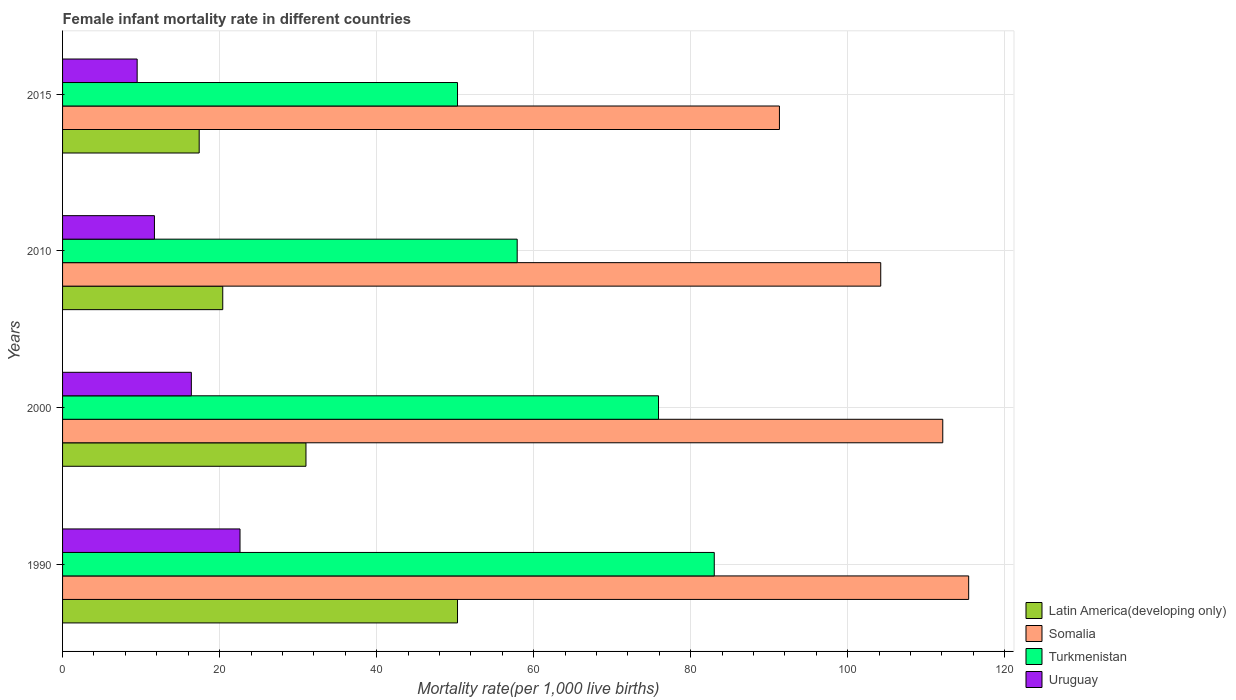How many different coloured bars are there?
Offer a very short reply. 4. How many groups of bars are there?
Give a very brief answer. 4. Are the number of bars per tick equal to the number of legend labels?
Your answer should be very brief. Yes. Are the number of bars on each tick of the Y-axis equal?
Your response must be concise. Yes. How many bars are there on the 4th tick from the top?
Ensure brevity in your answer.  4. How many bars are there on the 2nd tick from the bottom?
Provide a succinct answer. 4. What is the label of the 2nd group of bars from the top?
Offer a terse response. 2010. In how many cases, is the number of bars for a given year not equal to the number of legend labels?
Ensure brevity in your answer.  0. What is the female infant mortality rate in Uruguay in 2000?
Provide a succinct answer. 16.4. Across all years, what is the maximum female infant mortality rate in Somalia?
Give a very brief answer. 115.4. Across all years, what is the minimum female infant mortality rate in Somalia?
Keep it short and to the point. 91.3. In which year was the female infant mortality rate in Turkmenistan minimum?
Make the answer very short. 2015. What is the total female infant mortality rate in Latin America(developing only) in the graph?
Give a very brief answer. 119.1. What is the difference between the female infant mortality rate in Latin America(developing only) in 1990 and that in 2000?
Your response must be concise. 19.3. What is the difference between the female infant mortality rate in Somalia in 1990 and the female infant mortality rate in Latin America(developing only) in 2000?
Your answer should be compact. 84.4. What is the average female infant mortality rate in Somalia per year?
Your answer should be compact. 105.75. In the year 1990, what is the difference between the female infant mortality rate in Latin America(developing only) and female infant mortality rate in Turkmenistan?
Offer a terse response. -32.7. In how many years, is the female infant mortality rate in Uruguay greater than 88 ?
Give a very brief answer. 0. What is the ratio of the female infant mortality rate in Latin America(developing only) in 2000 to that in 2010?
Offer a terse response. 1.52. Is the difference between the female infant mortality rate in Latin America(developing only) in 1990 and 2010 greater than the difference between the female infant mortality rate in Turkmenistan in 1990 and 2010?
Offer a terse response. Yes. What is the difference between the highest and the second highest female infant mortality rate in Uruguay?
Keep it short and to the point. 6.2. What is the difference between the highest and the lowest female infant mortality rate in Somalia?
Ensure brevity in your answer.  24.1. In how many years, is the female infant mortality rate in Uruguay greater than the average female infant mortality rate in Uruguay taken over all years?
Ensure brevity in your answer.  2. What does the 3rd bar from the top in 1990 represents?
Provide a succinct answer. Somalia. What does the 2nd bar from the bottom in 1990 represents?
Your answer should be compact. Somalia. Are all the bars in the graph horizontal?
Provide a succinct answer. Yes. Does the graph contain grids?
Offer a very short reply. Yes. What is the title of the graph?
Provide a succinct answer. Female infant mortality rate in different countries. What is the label or title of the X-axis?
Make the answer very short. Mortality rate(per 1,0 live births). What is the label or title of the Y-axis?
Offer a terse response. Years. What is the Mortality rate(per 1,000 live births) of Latin America(developing only) in 1990?
Your answer should be very brief. 50.3. What is the Mortality rate(per 1,000 live births) in Somalia in 1990?
Your response must be concise. 115.4. What is the Mortality rate(per 1,000 live births) of Turkmenistan in 1990?
Make the answer very short. 83. What is the Mortality rate(per 1,000 live births) in Uruguay in 1990?
Keep it short and to the point. 22.6. What is the Mortality rate(per 1,000 live births) of Latin America(developing only) in 2000?
Provide a succinct answer. 31. What is the Mortality rate(per 1,000 live births) of Somalia in 2000?
Give a very brief answer. 112.1. What is the Mortality rate(per 1,000 live births) of Turkmenistan in 2000?
Make the answer very short. 75.9. What is the Mortality rate(per 1,000 live births) in Uruguay in 2000?
Give a very brief answer. 16.4. What is the Mortality rate(per 1,000 live births) of Latin America(developing only) in 2010?
Provide a short and direct response. 20.4. What is the Mortality rate(per 1,000 live births) of Somalia in 2010?
Give a very brief answer. 104.2. What is the Mortality rate(per 1,000 live births) in Turkmenistan in 2010?
Offer a terse response. 57.9. What is the Mortality rate(per 1,000 live births) of Somalia in 2015?
Your answer should be very brief. 91.3. What is the Mortality rate(per 1,000 live births) of Turkmenistan in 2015?
Offer a very short reply. 50.3. Across all years, what is the maximum Mortality rate(per 1,000 live births) of Latin America(developing only)?
Ensure brevity in your answer.  50.3. Across all years, what is the maximum Mortality rate(per 1,000 live births) in Somalia?
Offer a very short reply. 115.4. Across all years, what is the maximum Mortality rate(per 1,000 live births) of Turkmenistan?
Keep it short and to the point. 83. Across all years, what is the maximum Mortality rate(per 1,000 live births) in Uruguay?
Offer a very short reply. 22.6. Across all years, what is the minimum Mortality rate(per 1,000 live births) in Latin America(developing only)?
Your response must be concise. 17.4. Across all years, what is the minimum Mortality rate(per 1,000 live births) of Somalia?
Give a very brief answer. 91.3. Across all years, what is the minimum Mortality rate(per 1,000 live births) in Turkmenistan?
Provide a succinct answer. 50.3. Across all years, what is the minimum Mortality rate(per 1,000 live births) of Uruguay?
Ensure brevity in your answer.  9.5. What is the total Mortality rate(per 1,000 live births) in Latin America(developing only) in the graph?
Your answer should be very brief. 119.1. What is the total Mortality rate(per 1,000 live births) in Somalia in the graph?
Give a very brief answer. 423. What is the total Mortality rate(per 1,000 live births) of Turkmenistan in the graph?
Your answer should be very brief. 267.1. What is the total Mortality rate(per 1,000 live births) in Uruguay in the graph?
Your answer should be compact. 60.2. What is the difference between the Mortality rate(per 1,000 live births) of Latin America(developing only) in 1990 and that in 2000?
Offer a terse response. 19.3. What is the difference between the Mortality rate(per 1,000 live births) in Uruguay in 1990 and that in 2000?
Your response must be concise. 6.2. What is the difference between the Mortality rate(per 1,000 live births) in Latin America(developing only) in 1990 and that in 2010?
Give a very brief answer. 29.9. What is the difference between the Mortality rate(per 1,000 live births) in Somalia in 1990 and that in 2010?
Offer a terse response. 11.2. What is the difference between the Mortality rate(per 1,000 live births) of Turkmenistan in 1990 and that in 2010?
Offer a terse response. 25.1. What is the difference between the Mortality rate(per 1,000 live births) of Uruguay in 1990 and that in 2010?
Your answer should be very brief. 10.9. What is the difference between the Mortality rate(per 1,000 live births) of Latin America(developing only) in 1990 and that in 2015?
Keep it short and to the point. 32.9. What is the difference between the Mortality rate(per 1,000 live births) in Somalia in 1990 and that in 2015?
Provide a short and direct response. 24.1. What is the difference between the Mortality rate(per 1,000 live births) of Turkmenistan in 1990 and that in 2015?
Give a very brief answer. 32.7. What is the difference between the Mortality rate(per 1,000 live births) of Uruguay in 1990 and that in 2015?
Offer a terse response. 13.1. What is the difference between the Mortality rate(per 1,000 live births) in Latin America(developing only) in 2000 and that in 2010?
Provide a short and direct response. 10.6. What is the difference between the Mortality rate(per 1,000 live births) of Somalia in 2000 and that in 2010?
Make the answer very short. 7.9. What is the difference between the Mortality rate(per 1,000 live births) of Turkmenistan in 2000 and that in 2010?
Give a very brief answer. 18. What is the difference between the Mortality rate(per 1,000 live births) in Somalia in 2000 and that in 2015?
Keep it short and to the point. 20.8. What is the difference between the Mortality rate(per 1,000 live births) in Turkmenistan in 2000 and that in 2015?
Your answer should be very brief. 25.6. What is the difference between the Mortality rate(per 1,000 live births) of Latin America(developing only) in 2010 and that in 2015?
Your answer should be very brief. 3. What is the difference between the Mortality rate(per 1,000 live births) in Somalia in 2010 and that in 2015?
Provide a succinct answer. 12.9. What is the difference between the Mortality rate(per 1,000 live births) of Uruguay in 2010 and that in 2015?
Your response must be concise. 2.2. What is the difference between the Mortality rate(per 1,000 live births) of Latin America(developing only) in 1990 and the Mortality rate(per 1,000 live births) of Somalia in 2000?
Your response must be concise. -61.8. What is the difference between the Mortality rate(per 1,000 live births) in Latin America(developing only) in 1990 and the Mortality rate(per 1,000 live births) in Turkmenistan in 2000?
Your response must be concise. -25.6. What is the difference between the Mortality rate(per 1,000 live births) in Latin America(developing only) in 1990 and the Mortality rate(per 1,000 live births) in Uruguay in 2000?
Keep it short and to the point. 33.9. What is the difference between the Mortality rate(per 1,000 live births) of Somalia in 1990 and the Mortality rate(per 1,000 live births) of Turkmenistan in 2000?
Give a very brief answer. 39.5. What is the difference between the Mortality rate(per 1,000 live births) in Turkmenistan in 1990 and the Mortality rate(per 1,000 live births) in Uruguay in 2000?
Make the answer very short. 66.6. What is the difference between the Mortality rate(per 1,000 live births) in Latin America(developing only) in 1990 and the Mortality rate(per 1,000 live births) in Somalia in 2010?
Offer a terse response. -53.9. What is the difference between the Mortality rate(per 1,000 live births) in Latin America(developing only) in 1990 and the Mortality rate(per 1,000 live births) in Uruguay in 2010?
Ensure brevity in your answer.  38.6. What is the difference between the Mortality rate(per 1,000 live births) of Somalia in 1990 and the Mortality rate(per 1,000 live births) of Turkmenistan in 2010?
Your answer should be compact. 57.5. What is the difference between the Mortality rate(per 1,000 live births) of Somalia in 1990 and the Mortality rate(per 1,000 live births) of Uruguay in 2010?
Your response must be concise. 103.7. What is the difference between the Mortality rate(per 1,000 live births) of Turkmenistan in 1990 and the Mortality rate(per 1,000 live births) of Uruguay in 2010?
Make the answer very short. 71.3. What is the difference between the Mortality rate(per 1,000 live births) in Latin America(developing only) in 1990 and the Mortality rate(per 1,000 live births) in Somalia in 2015?
Ensure brevity in your answer.  -41. What is the difference between the Mortality rate(per 1,000 live births) in Latin America(developing only) in 1990 and the Mortality rate(per 1,000 live births) in Uruguay in 2015?
Provide a succinct answer. 40.8. What is the difference between the Mortality rate(per 1,000 live births) of Somalia in 1990 and the Mortality rate(per 1,000 live births) of Turkmenistan in 2015?
Your answer should be compact. 65.1. What is the difference between the Mortality rate(per 1,000 live births) of Somalia in 1990 and the Mortality rate(per 1,000 live births) of Uruguay in 2015?
Provide a short and direct response. 105.9. What is the difference between the Mortality rate(per 1,000 live births) in Turkmenistan in 1990 and the Mortality rate(per 1,000 live births) in Uruguay in 2015?
Your answer should be very brief. 73.5. What is the difference between the Mortality rate(per 1,000 live births) of Latin America(developing only) in 2000 and the Mortality rate(per 1,000 live births) of Somalia in 2010?
Provide a short and direct response. -73.2. What is the difference between the Mortality rate(per 1,000 live births) of Latin America(developing only) in 2000 and the Mortality rate(per 1,000 live births) of Turkmenistan in 2010?
Give a very brief answer. -26.9. What is the difference between the Mortality rate(per 1,000 live births) of Latin America(developing only) in 2000 and the Mortality rate(per 1,000 live births) of Uruguay in 2010?
Provide a succinct answer. 19.3. What is the difference between the Mortality rate(per 1,000 live births) of Somalia in 2000 and the Mortality rate(per 1,000 live births) of Turkmenistan in 2010?
Your answer should be very brief. 54.2. What is the difference between the Mortality rate(per 1,000 live births) in Somalia in 2000 and the Mortality rate(per 1,000 live births) in Uruguay in 2010?
Offer a terse response. 100.4. What is the difference between the Mortality rate(per 1,000 live births) of Turkmenistan in 2000 and the Mortality rate(per 1,000 live births) of Uruguay in 2010?
Your answer should be compact. 64.2. What is the difference between the Mortality rate(per 1,000 live births) of Latin America(developing only) in 2000 and the Mortality rate(per 1,000 live births) of Somalia in 2015?
Ensure brevity in your answer.  -60.3. What is the difference between the Mortality rate(per 1,000 live births) of Latin America(developing only) in 2000 and the Mortality rate(per 1,000 live births) of Turkmenistan in 2015?
Your answer should be very brief. -19.3. What is the difference between the Mortality rate(per 1,000 live births) in Latin America(developing only) in 2000 and the Mortality rate(per 1,000 live births) in Uruguay in 2015?
Provide a short and direct response. 21.5. What is the difference between the Mortality rate(per 1,000 live births) in Somalia in 2000 and the Mortality rate(per 1,000 live births) in Turkmenistan in 2015?
Keep it short and to the point. 61.8. What is the difference between the Mortality rate(per 1,000 live births) in Somalia in 2000 and the Mortality rate(per 1,000 live births) in Uruguay in 2015?
Offer a very short reply. 102.6. What is the difference between the Mortality rate(per 1,000 live births) of Turkmenistan in 2000 and the Mortality rate(per 1,000 live births) of Uruguay in 2015?
Offer a very short reply. 66.4. What is the difference between the Mortality rate(per 1,000 live births) in Latin America(developing only) in 2010 and the Mortality rate(per 1,000 live births) in Somalia in 2015?
Ensure brevity in your answer.  -70.9. What is the difference between the Mortality rate(per 1,000 live births) of Latin America(developing only) in 2010 and the Mortality rate(per 1,000 live births) of Turkmenistan in 2015?
Ensure brevity in your answer.  -29.9. What is the difference between the Mortality rate(per 1,000 live births) of Latin America(developing only) in 2010 and the Mortality rate(per 1,000 live births) of Uruguay in 2015?
Offer a very short reply. 10.9. What is the difference between the Mortality rate(per 1,000 live births) in Somalia in 2010 and the Mortality rate(per 1,000 live births) in Turkmenistan in 2015?
Provide a short and direct response. 53.9. What is the difference between the Mortality rate(per 1,000 live births) of Somalia in 2010 and the Mortality rate(per 1,000 live births) of Uruguay in 2015?
Offer a terse response. 94.7. What is the difference between the Mortality rate(per 1,000 live births) of Turkmenistan in 2010 and the Mortality rate(per 1,000 live births) of Uruguay in 2015?
Your answer should be compact. 48.4. What is the average Mortality rate(per 1,000 live births) in Latin America(developing only) per year?
Ensure brevity in your answer.  29.77. What is the average Mortality rate(per 1,000 live births) in Somalia per year?
Your answer should be very brief. 105.75. What is the average Mortality rate(per 1,000 live births) in Turkmenistan per year?
Offer a terse response. 66.78. What is the average Mortality rate(per 1,000 live births) in Uruguay per year?
Provide a succinct answer. 15.05. In the year 1990, what is the difference between the Mortality rate(per 1,000 live births) of Latin America(developing only) and Mortality rate(per 1,000 live births) of Somalia?
Your response must be concise. -65.1. In the year 1990, what is the difference between the Mortality rate(per 1,000 live births) in Latin America(developing only) and Mortality rate(per 1,000 live births) in Turkmenistan?
Provide a succinct answer. -32.7. In the year 1990, what is the difference between the Mortality rate(per 1,000 live births) in Latin America(developing only) and Mortality rate(per 1,000 live births) in Uruguay?
Ensure brevity in your answer.  27.7. In the year 1990, what is the difference between the Mortality rate(per 1,000 live births) of Somalia and Mortality rate(per 1,000 live births) of Turkmenistan?
Make the answer very short. 32.4. In the year 1990, what is the difference between the Mortality rate(per 1,000 live births) of Somalia and Mortality rate(per 1,000 live births) of Uruguay?
Offer a very short reply. 92.8. In the year 1990, what is the difference between the Mortality rate(per 1,000 live births) of Turkmenistan and Mortality rate(per 1,000 live births) of Uruguay?
Offer a terse response. 60.4. In the year 2000, what is the difference between the Mortality rate(per 1,000 live births) of Latin America(developing only) and Mortality rate(per 1,000 live births) of Somalia?
Provide a succinct answer. -81.1. In the year 2000, what is the difference between the Mortality rate(per 1,000 live births) in Latin America(developing only) and Mortality rate(per 1,000 live births) in Turkmenistan?
Your response must be concise. -44.9. In the year 2000, what is the difference between the Mortality rate(per 1,000 live births) of Somalia and Mortality rate(per 1,000 live births) of Turkmenistan?
Your response must be concise. 36.2. In the year 2000, what is the difference between the Mortality rate(per 1,000 live births) in Somalia and Mortality rate(per 1,000 live births) in Uruguay?
Offer a very short reply. 95.7. In the year 2000, what is the difference between the Mortality rate(per 1,000 live births) of Turkmenistan and Mortality rate(per 1,000 live births) of Uruguay?
Provide a succinct answer. 59.5. In the year 2010, what is the difference between the Mortality rate(per 1,000 live births) of Latin America(developing only) and Mortality rate(per 1,000 live births) of Somalia?
Ensure brevity in your answer.  -83.8. In the year 2010, what is the difference between the Mortality rate(per 1,000 live births) in Latin America(developing only) and Mortality rate(per 1,000 live births) in Turkmenistan?
Provide a short and direct response. -37.5. In the year 2010, what is the difference between the Mortality rate(per 1,000 live births) in Latin America(developing only) and Mortality rate(per 1,000 live births) in Uruguay?
Give a very brief answer. 8.7. In the year 2010, what is the difference between the Mortality rate(per 1,000 live births) in Somalia and Mortality rate(per 1,000 live births) in Turkmenistan?
Your answer should be very brief. 46.3. In the year 2010, what is the difference between the Mortality rate(per 1,000 live births) of Somalia and Mortality rate(per 1,000 live births) of Uruguay?
Provide a short and direct response. 92.5. In the year 2010, what is the difference between the Mortality rate(per 1,000 live births) of Turkmenistan and Mortality rate(per 1,000 live births) of Uruguay?
Make the answer very short. 46.2. In the year 2015, what is the difference between the Mortality rate(per 1,000 live births) in Latin America(developing only) and Mortality rate(per 1,000 live births) in Somalia?
Ensure brevity in your answer.  -73.9. In the year 2015, what is the difference between the Mortality rate(per 1,000 live births) of Latin America(developing only) and Mortality rate(per 1,000 live births) of Turkmenistan?
Your answer should be compact. -32.9. In the year 2015, what is the difference between the Mortality rate(per 1,000 live births) in Latin America(developing only) and Mortality rate(per 1,000 live births) in Uruguay?
Offer a terse response. 7.9. In the year 2015, what is the difference between the Mortality rate(per 1,000 live births) of Somalia and Mortality rate(per 1,000 live births) of Turkmenistan?
Offer a very short reply. 41. In the year 2015, what is the difference between the Mortality rate(per 1,000 live births) in Somalia and Mortality rate(per 1,000 live births) in Uruguay?
Offer a very short reply. 81.8. In the year 2015, what is the difference between the Mortality rate(per 1,000 live births) of Turkmenistan and Mortality rate(per 1,000 live births) of Uruguay?
Your response must be concise. 40.8. What is the ratio of the Mortality rate(per 1,000 live births) of Latin America(developing only) in 1990 to that in 2000?
Provide a short and direct response. 1.62. What is the ratio of the Mortality rate(per 1,000 live births) of Somalia in 1990 to that in 2000?
Make the answer very short. 1.03. What is the ratio of the Mortality rate(per 1,000 live births) in Turkmenistan in 1990 to that in 2000?
Your answer should be very brief. 1.09. What is the ratio of the Mortality rate(per 1,000 live births) of Uruguay in 1990 to that in 2000?
Offer a terse response. 1.38. What is the ratio of the Mortality rate(per 1,000 live births) of Latin America(developing only) in 1990 to that in 2010?
Ensure brevity in your answer.  2.47. What is the ratio of the Mortality rate(per 1,000 live births) of Somalia in 1990 to that in 2010?
Provide a succinct answer. 1.11. What is the ratio of the Mortality rate(per 1,000 live births) of Turkmenistan in 1990 to that in 2010?
Ensure brevity in your answer.  1.43. What is the ratio of the Mortality rate(per 1,000 live births) of Uruguay in 1990 to that in 2010?
Provide a short and direct response. 1.93. What is the ratio of the Mortality rate(per 1,000 live births) in Latin America(developing only) in 1990 to that in 2015?
Keep it short and to the point. 2.89. What is the ratio of the Mortality rate(per 1,000 live births) of Somalia in 1990 to that in 2015?
Your answer should be compact. 1.26. What is the ratio of the Mortality rate(per 1,000 live births) in Turkmenistan in 1990 to that in 2015?
Keep it short and to the point. 1.65. What is the ratio of the Mortality rate(per 1,000 live births) of Uruguay in 1990 to that in 2015?
Your answer should be compact. 2.38. What is the ratio of the Mortality rate(per 1,000 live births) of Latin America(developing only) in 2000 to that in 2010?
Make the answer very short. 1.52. What is the ratio of the Mortality rate(per 1,000 live births) in Somalia in 2000 to that in 2010?
Offer a very short reply. 1.08. What is the ratio of the Mortality rate(per 1,000 live births) in Turkmenistan in 2000 to that in 2010?
Give a very brief answer. 1.31. What is the ratio of the Mortality rate(per 1,000 live births) in Uruguay in 2000 to that in 2010?
Give a very brief answer. 1.4. What is the ratio of the Mortality rate(per 1,000 live births) in Latin America(developing only) in 2000 to that in 2015?
Your answer should be compact. 1.78. What is the ratio of the Mortality rate(per 1,000 live births) in Somalia in 2000 to that in 2015?
Your answer should be very brief. 1.23. What is the ratio of the Mortality rate(per 1,000 live births) in Turkmenistan in 2000 to that in 2015?
Provide a short and direct response. 1.51. What is the ratio of the Mortality rate(per 1,000 live births) in Uruguay in 2000 to that in 2015?
Your answer should be compact. 1.73. What is the ratio of the Mortality rate(per 1,000 live births) of Latin America(developing only) in 2010 to that in 2015?
Offer a very short reply. 1.17. What is the ratio of the Mortality rate(per 1,000 live births) of Somalia in 2010 to that in 2015?
Ensure brevity in your answer.  1.14. What is the ratio of the Mortality rate(per 1,000 live births) of Turkmenistan in 2010 to that in 2015?
Keep it short and to the point. 1.15. What is the ratio of the Mortality rate(per 1,000 live births) of Uruguay in 2010 to that in 2015?
Offer a terse response. 1.23. What is the difference between the highest and the second highest Mortality rate(per 1,000 live births) in Latin America(developing only)?
Give a very brief answer. 19.3. What is the difference between the highest and the second highest Mortality rate(per 1,000 live births) of Turkmenistan?
Ensure brevity in your answer.  7.1. What is the difference between the highest and the lowest Mortality rate(per 1,000 live births) of Latin America(developing only)?
Offer a terse response. 32.9. What is the difference between the highest and the lowest Mortality rate(per 1,000 live births) of Somalia?
Your response must be concise. 24.1. What is the difference between the highest and the lowest Mortality rate(per 1,000 live births) of Turkmenistan?
Make the answer very short. 32.7. What is the difference between the highest and the lowest Mortality rate(per 1,000 live births) in Uruguay?
Offer a terse response. 13.1. 